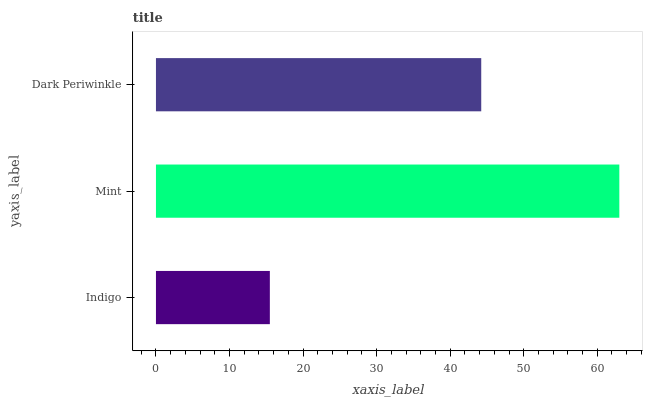Is Indigo the minimum?
Answer yes or no. Yes. Is Mint the maximum?
Answer yes or no. Yes. Is Dark Periwinkle the minimum?
Answer yes or no. No. Is Dark Periwinkle the maximum?
Answer yes or no. No. Is Mint greater than Dark Periwinkle?
Answer yes or no. Yes. Is Dark Periwinkle less than Mint?
Answer yes or no. Yes. Is Dark Periwinkle greater than Mint?
Answer yes or no. No. Is Mint less than Dark Periwinkle?
Answer yes or no. No. Is Dark Periwinkle the high median?
Answer yes or no. Yes. Is Dark Periwinkle the low median?
Answer yes or no. Yes. Is Indigo the high median?
Answer yes or no. No. Is Indigo the low median?
Answer yes or no. No. 